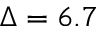<formula> <loc_0><loc_0><loc_500><loc_500>\Delta = 6 . 7</formula> 